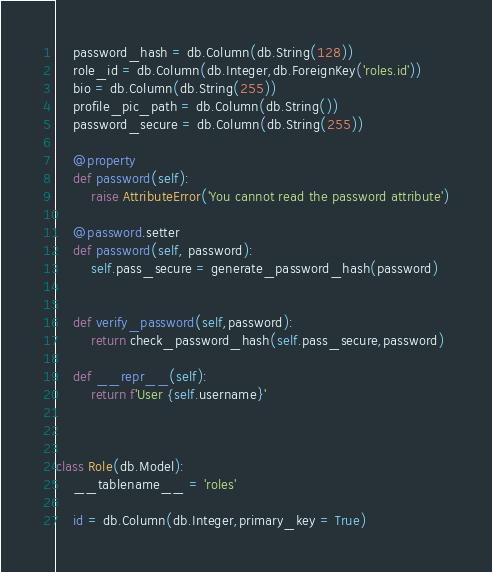<code> <loc_0><loc_0><loc_500><loc_500><_Python_>    password_hash = db.Column(db.String(128))
    role_id = db.Column(db.Integer,db.ForeignKey('roles.id'))
    bio = db.Column(db.String(255))
    profile_pic_path = db.Column(db.String())
    password_secure = db.Column(db.String(255))
    
    @property
    def password(self):
        raise AttributeError('You cannot read the password attribute')

    @password.setter
    def password(self, password):
        self.pass_secure = generate_password_hash(password)


    def verify_password(self,password):
        return check_password_hash(self.pass_secure,password)

    def __repr__(self):
        return f'User {self.username}'



class Role(db.Model):
    __tablename__ = 'roles'

    id = db.Column(db.Integer,primary_key = True)</code> 